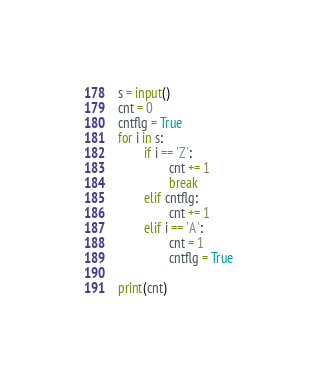Convert code to text. <code><loc_0><loc_0><loc_500><loc_500><_Python_>s = input()
cnt = 0
cntflg = True
for i in s:
        if i == 'Z':
                cnt += 1
                break
        elif cntflg:
                cnt += 1
        elif i == 'A':
                cnt = 1
                cntflg = True

print(cnt)
</code> 